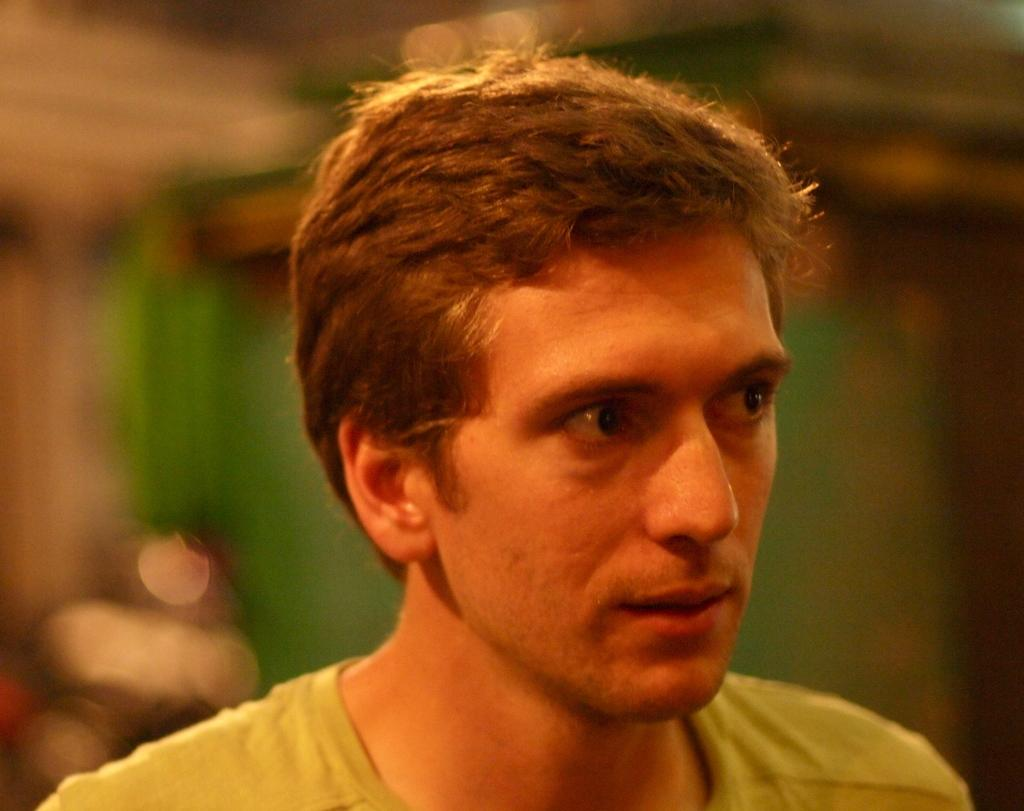What is the main subject of the image? There is a face of a person in the image. Can you describe any other elements in the image besides the person's face? Yes, there are other objects in the background of the image. What type of pancake is the person sneezing on in the image? There is no pancake or sneezing present in the image; it only features the face of a person and other objects in the background. 